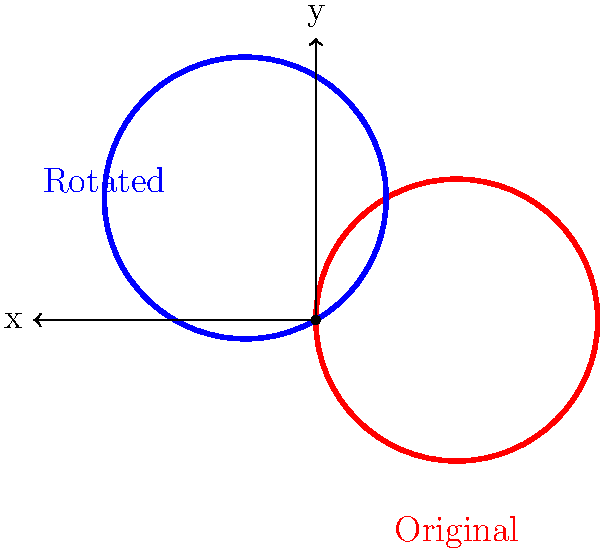A heart-shaped symbol represents your gratitude towards the paramedic and medical student who saved your life. If you want to rotate this symbol to create a design for a thank-you card, by how many degrees should you rotate the original heart shape to obtain the blue heart shown in the diagram? To find the angle of rotation, we can follow these steps:

1) First, observe that the original red heart is oriented vertically along the y-axis.

2) The rotated blue heart appears to have been rotated counterclockwise from the original position.

3) In geometry, counterclockwise rotations are considered positive.

4) Looking at the diagram, we can see that the blue heart has been rotated such that its "point" is now in the upper-left quadrant of the coordinate plane.

5) The coordinate plane is divided into four quadrants, each spanning 90°.

6) The blue heart's point is approximately one-third of the way through the second quadrant (counting counterclockwise from the positive x-axis).

7) One-third of 90° is 30°.

8) Therefore, the total rotation is: 90° (to reach the start of the second quadrant) + 30° (to reach the final position) = 120°.

This matches the rotation used in the Asymptote code to generate the diagram: rotate(120)*heart.
Answer: 120° 